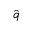<formula> <loc_0><loc_0><loc_500><loc_500>\hat { q }</formula> 